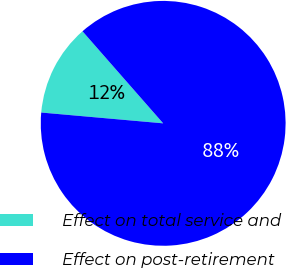<chart> <loc_0><loc_0><loc_500><loc_500><pie_chart><fcel>Effect on total service and<fcel>Effect on post-retirement<nl><fcel>12.14%<fcel>87.86%<nl></chart> 